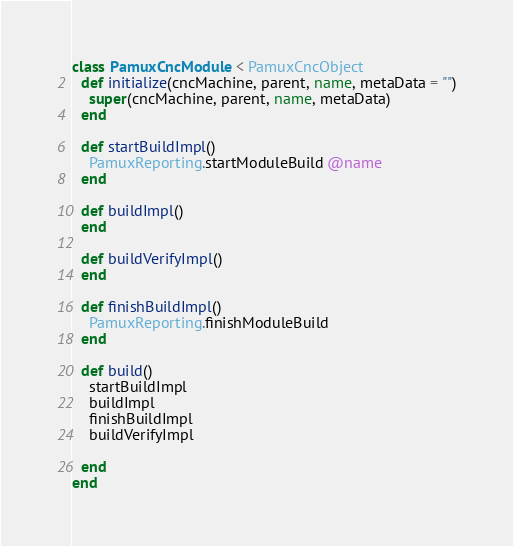<code> <loc_0><loc_0><loc_500><loc_500><_Ruby_>class PamuxCncModule < PamuxCncObject
  def initialize(cncMachine, parent, name, metaData = "")
    super(cncMachine, parent, name, metaData)
  end
  
  def startBuildImpl()
    PamuxReporting.startModuleBuild @name
  end
  
  def buildImpl()
  end
  
  def buildVerifyImpl()
  end
  
  def finishBuildImpl()
    PamuxReporting.finishModuleBuild
  end
  
  def build()
    startBuildImpl
    buildImpl
    finishBuildImpl
    buildVerifyImpl
    
  end  
end</code> 